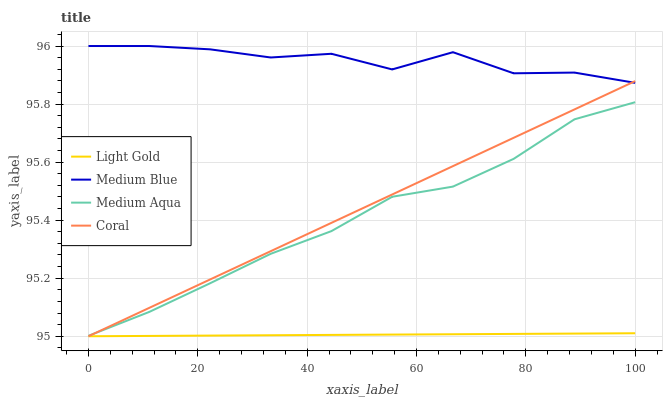Does Light Gold have the minimum area under the curve?
Answer yes or no. Yes. Does Medium Blue have the maximum area under the curve?
Answer yes or no. Yes. Does Coral have the minimum area under the curve?
Answer yes or no. No. Does Coral have the maximum area under the curve?
Answer yes or no. No. Is Light Gold the smoothest?
Answer yes or no. Yes. Is Medium Blue the roughest?
Answer yes or no. Yes. Is Coral the smoothest?
Answer yes or no. No. Is Coral the roughest?
Answer yes or no. No. Does Coral have the lowest value?
Answer yes or no. Yes. Does Medium Blue have the lowest value?
Answer yes or no. No. Does Medium Blue have the highest value?
Answer yes or no. Yes. Does Coral have the highest value?
Answer yes or no. No. Is Medium Aqua less than Medium Blue?
Answer yes or no. Yes. Is Medium Blue greater than Medium Aqua?
Answer yes or no. Yes. Does Coral intersect Light Gold?
Answer yes or no. Yes. Is Coral less than Light Gold?
Answer yes or no. No. Is Coral greater than Light Gold?
Answer yes or no. No. Does Medium Aqua intersect Medium Blue?
Answer yes or no. No. 